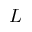Convert formula to latex. <formula><loc_0><loc_0><loc_500><loc_500>L</formula> 